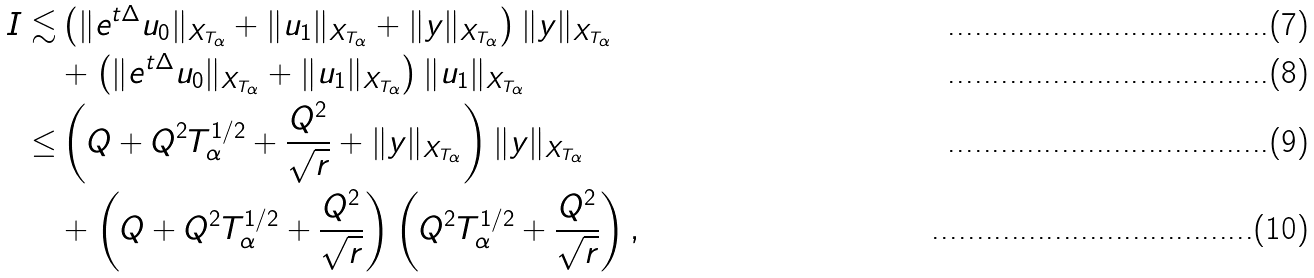<formula> <loc_0><loc_0><loc_500><loc_500>I \lesssim & \left ( \| e ^ { t \Delta } u _ { 0 } \| _ { X _ { T _ { \alpha } } } + \| u _ { 1 } \| _ { X _ { T _ { \alpha } } } + \| y \| _ { X _ { T _ { \alpha } } } \right ) \| y \| _ { X _ { T _ { \alpha } } } \\ & + \left ( \| e ^ { t \Delta } u _ { 0 } \| _ { X _ { T _ { \alpha } } } + \| u _ { 1 } \| _ { X _ { T _ { \alpha } } } \right ) \| u _ { 1 } \| _ { X _ { T _ { \alpha } } } \\ \leq & \left ( Q + Q ^ { 2 } T _ { \alpha } ^ { 1 / 2 } + \frac { Q ^ { 2 } } { \sqrt { r } } + \| y \| _ { X _ { T _ { \alpha } } } \right ) \| y \| _ { X _ { T _ { \alpha } } } \\ & + \left ( Q + Q ^ { 2 } T _ { \alpha } ^ { 1 / 2 } + \frac { Q ^ { 2 } } { \sqrt { r } } \right ) \left ( Q ^ { 2 } T _ { \alpha } ^ { 1 / 2 } + \frac { Q ^ { 2 } } { \sqrt { r } } \right ) ,</formula> 